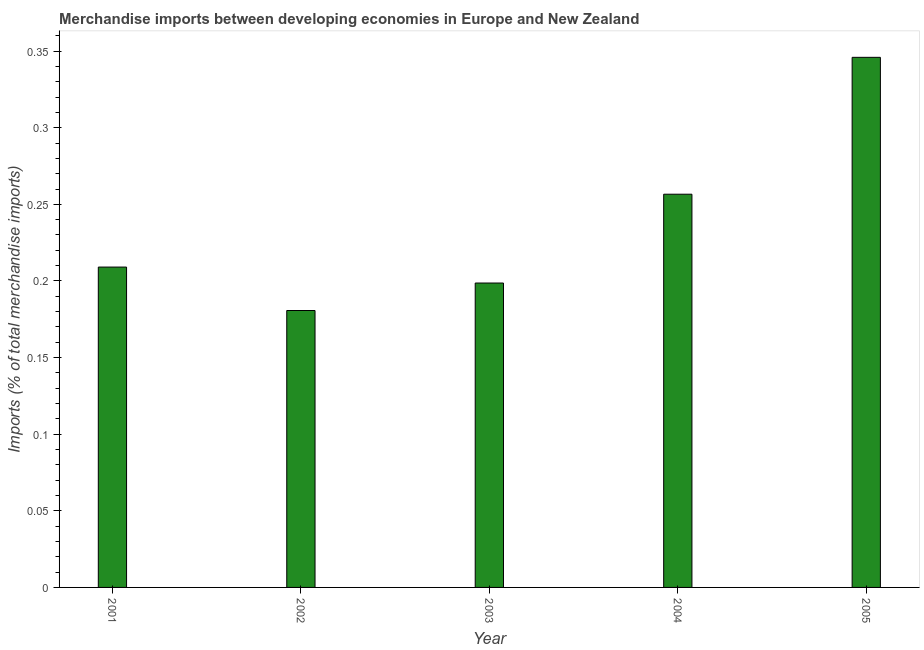Does the graph contain grids?
Your response must be concise. No. What is the title of the graph?
Ensure brevity in your answer.  Merchandise imports between developing economies in Europe and New Zealand. What is the label or title of the X-axis?
Your answer should be compact. Year. What is the label or title of the Y-axis?
Make the answer very short. Imports (% of total merchandise imports). What is the merchandise imports in 2001?
Your response must be concise. 0.21. Across all years, what is the maximum merchandise imports?
Your answer should be compact. 0.35. Across all years, what is the minimum merchandise imports?
Offer a terse response. 0.18. In which year was the merchandise imports maximum?
Your answer should be very brief. 2005. What is the sum of the merchandise imports?
Give a very brief answer. 1.19. What is the difference between the merchandise imports in 2002 and 2004?
Make the answer very short. -0.08. What is the average merchandise imports per year?
Your answer should be very brief. 0.24. What is the median merchandise imports?
Your answer should be compact. 0.21. Do a majority of the years between 2004 and 2005 (inclusive) have merchandise imports greater than 0.2 %?
Your response must be concise. Yes. What is the ratio of the merchandise imports in 2001 to that in 2003?
Your answer should be compact. 1.05. What is the difference between the highest and the second highest merchandise imports?
Make the answer very short. 0.09. Is the sum of the merchandise imports in 2002 and 2005 greater than the maximum merchandise imports across all years?
Make the answer very short. Yes. What is the difference between the highest and the lowest merchandise imports?
Provide a succinct answer. 0.17. In how many years, is the merchandise imports greater than the average merchandise imports taken over all years?
Offer a terse response. 2. How many bars are there?
Offer a terse response. 5. Are all the bars in the graph horizontal?
Your answer should be very brief. No. How many years are there in the graph?
Provide a short and direct response. 5. What is the difference between two consecutive major ticks on the Y-axis?
Give a very brief answer. 0.05. Are the values on the major ticks of Y-axis written in scientific E-notation?
Offer a very short reply. No. What is the Imports (% of total merchandise imports) in 2001?
Offer a very short reply. 0.21. What is the Imports (% of total merchandise imports) in 2002?
Keep it short and to the point. 0.18. What is the Imports (% of total merchandise imports) of 2003?
Keep it short and to the point. 0.2. What is the Imports (% of total merchandise imports) in 2004?
Make the answer very short. 0.26. What is the Imports (% of total merchandise imports) in 2005?
Ensure brevity in your answer.  0.35. What is the difference between the Imports (% of total merchandise imports) in 2001 and 2002?
Your answer should be compact. 0.03. What is the difference between the Imports (% of total merchandise imports) in 2001 and 2003?
Give a very brief answer. 0.01. What is the difference between the Imports (% of total merchandise imports) in 2001 and 2004?
Your answer should be compact. -0.05. What is the difference between the Imports (% of total merchandise imports) in 2001 and 2005?
Make the answer very short. -0.14. What is the difference between the Imports (% of total merchandise imports) in 2002 and 2003?
Your answer should be compact. -0.02. What is the difference between the Imports (% of total merchandise imports) in 2002 and 2004?
Ensure brevity in your answer.  -0.08. What is the difference between the Imports (% of total merchandise imports) in 2002 and 2005?
Provide a short and direct response. -0.17. What is the difference between the Imports (% of total merchandise imports) in 2003 and 2004?
Make the answer very short. -0.06. What is the difference between the Imports (% of total merchandise imports) in 2003 and 2005?
Give a very brief answer. -0.15. What is the difference between the Imports (% of total merchandise imports) in 2004 and 2005?
Offer a terse response. -0.09. What is the ratio of the Imports (% of total merchandise imports) in 2001 to that in 2002?
Offer a terse response. 1.16. What is the ratio of the Imports (% of total merchandise imports) in 2001 to that in 2003?
Offer a very short reply. 1.05. What is the ratio of the Imports (% of total merchandise imports) in 2001 to that in 2004?
Keep it short and to the point. 0.81. What is the ratio of the Imports (% of total merchandise imports) in 2001 to that in 2005?
Offer a very short reply. 0.6. What is the ratio of the Imports (% of total merchandise imports) in 2002 to that in 2003?
Keep it short and to the point. 0.91. What is the ratio of the Imports (% of total merchandise imports) in 2002 to that in 2004?
Provide a succinct answer. 0.7. What is the ratio of the Imports (% of total merchandise imports) in 2002 to that in 2005?
Provide a short and direct response. 0.52. What is the ratio of the Imports (% of total merchandise imports) in 2003 to that in 2004?
Keep it short and to the point. 0.77. What is the ratio of the Imports (% of total merchandise imports) in 2003 to that in 2005?
Offer a terse response. 0.57. What is the ratio of the Imports (% of total merchandise imports) in 2004 to that in 2005?
Offer a terse response. 0.74. 